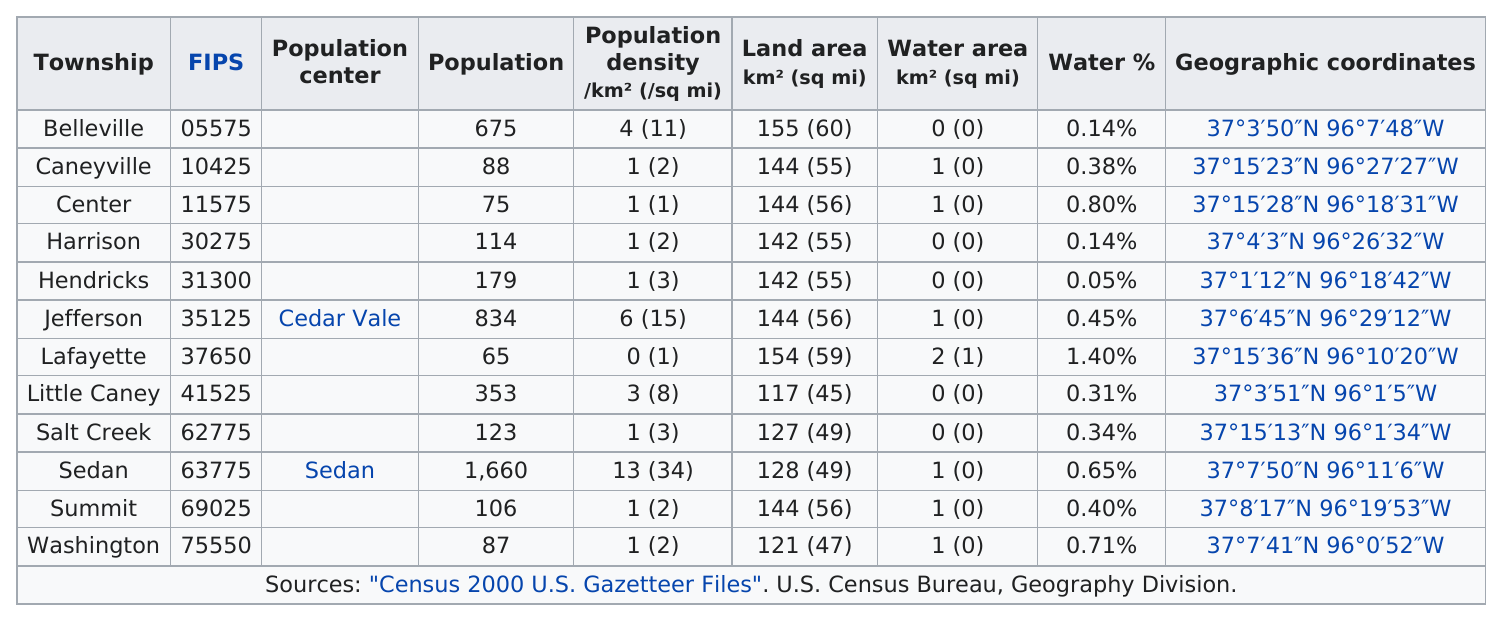Outline some significant characteristics in this image. The town with the highest population density is Sedan. Sedan Township has the greatest population total of all townships. Caneyville, Jefferson, and Summit townships all have the same land area as the center. Five townships have no water area. Out of the townships in the area, how many have a water area of 0 km? 